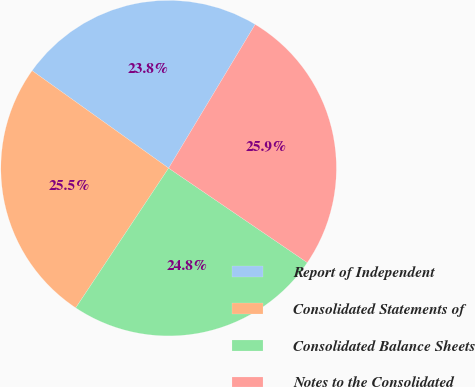Convert chart. <chart><loc_0><loc_0><loc_500><loc_500><pie_chart><fcel>Report of Independent<fcel>Consolidated Statements of<fcel>Consolidated Balance Sheets<fcel>Notes to the Consolidated<nl><fcel>23.76%<fcel>25.53%<fcel>24.82%<fcel>25.89%<nl></chart> 